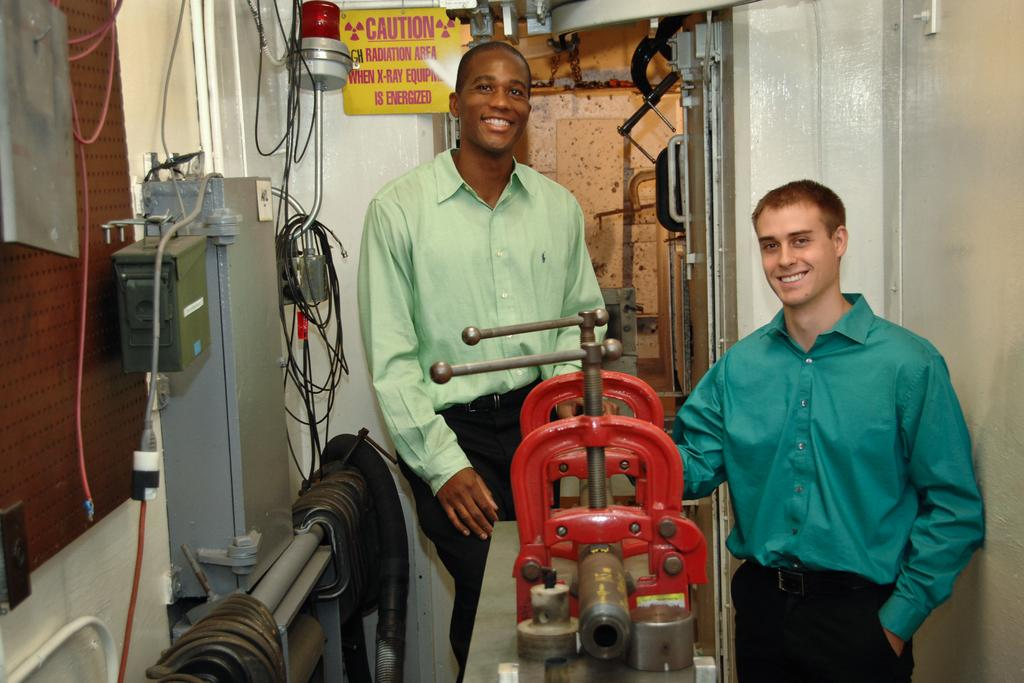How many people are in the image? There are two people in the image. Where are the people standing? The people are standing in a machine room. What else can be seen in the image besides the people? There are machines, wires, and boards in the image. What type of straw is being used to point at the machines in the image? There is no straw present in the image, and the people are not pointing at the machines. 